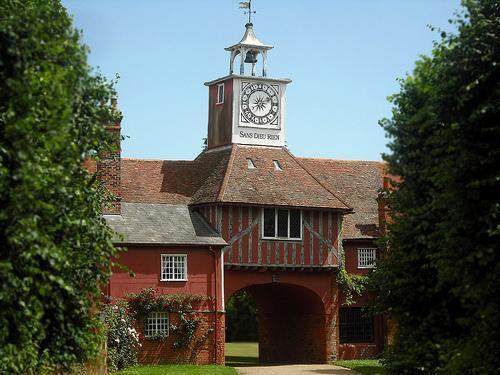How many towers are seen?
Give a very brief answer. 1. 